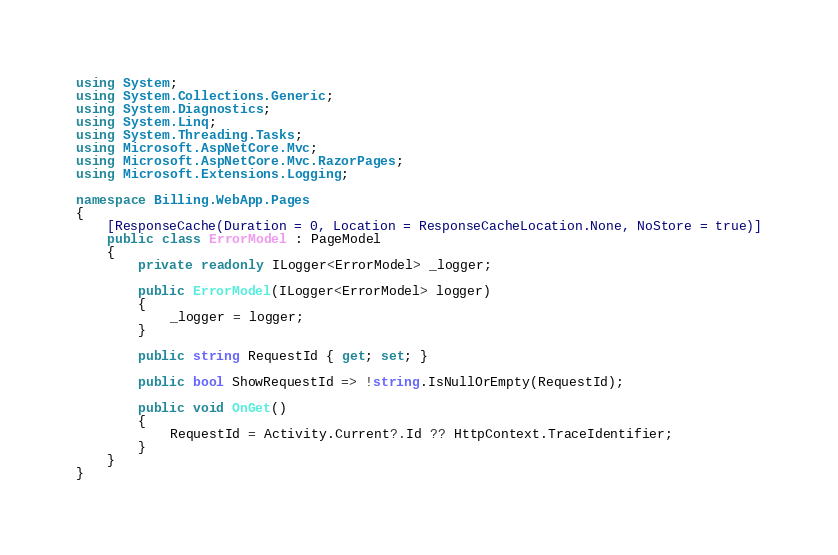Convert code to text. <code><loc_0><loc_0><loc_500><loc_500><_C#_>using System;
using System.Collections.Generic;
using System.Diagnostics;
using System.Linq;
using System.Threading.Tasks;
using Microsoft.AspNetCore.Mvc;
using Microsoft.AspNetCore.Mvc.RazorPages;
using Microsoft.Extensions.Logging;

namespace Billing.WebApp.Pages
{
    [ResponseCache(Duration = 0, Location = ResponseCacheLocation.None, NoStore = true)]
    public class ErrorModel : PageModel
    {
        private readonly ILogger<ErrorModel> _logger;

        public ErrorModel(ILogger<ErrorModel> logger)
        {
            _logger = logger;
        }

        public string RequestId { get; set; }

        public bool ShowRequestId => !string.IsNullOrEmpty(RequestId);

        public void OnGet()
        {
            RequestId = Activity.Current?.Id ?? HttpContext.TraceIdentifier;
        }
    }
}
</code> 